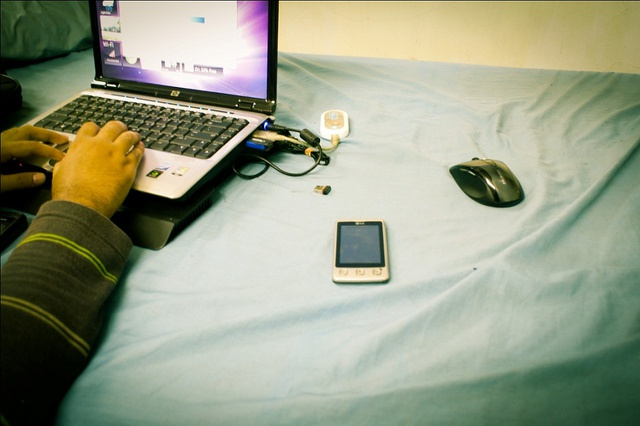Describe the objects in this image and their specific colors. I can see bed in black, lightgray, darkgray, and beige tones, people in black, olive, and orange tones, laptop in black, lightgray, darkgreen, and gray tones, cell phone in black, gray, tan, and beige tones, and mouse in black, darkgreen, and tan tones in this image. 